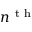<formula> <loc_0><loc_0><loc_500><loc_500>n ^ { t h }</formula> 